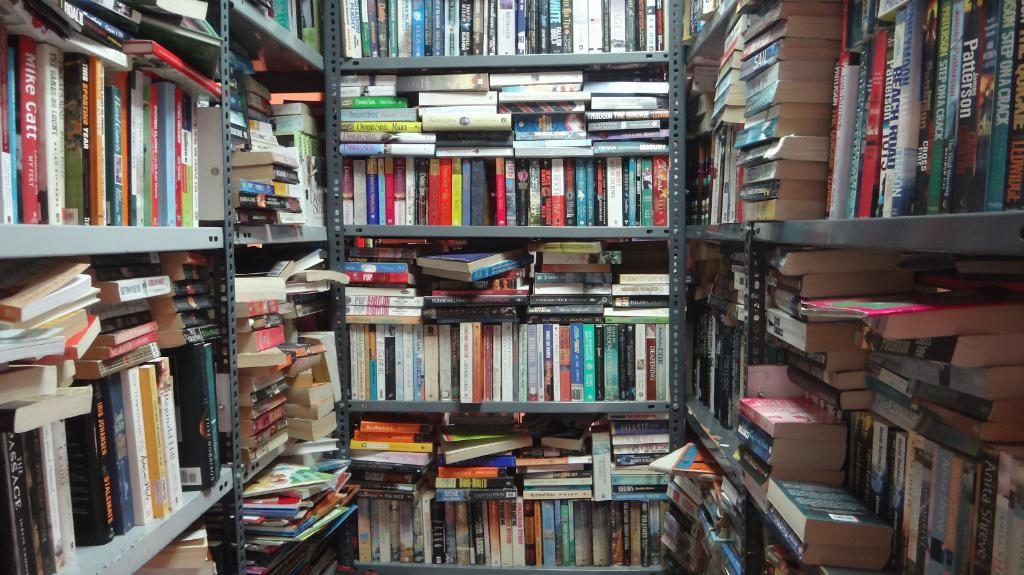What objects are present in the image? There are books in the image. How are the books organized in the image? The books are arranged in racks. Can you describe the orientation of some of the books in the image? Some books are in a vertical position, while others are in a horizontal position. What type of cup is placed on top of the books in the image? There is no cup present in the image; it only features books arranged in racks. 